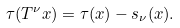<formula> <loc_0><loc_0><loc_500><loc_500>\tau ( T ^ { \nu } x ) = \tau ( x ) - s _ { \nu } ( x ) .</formula> 